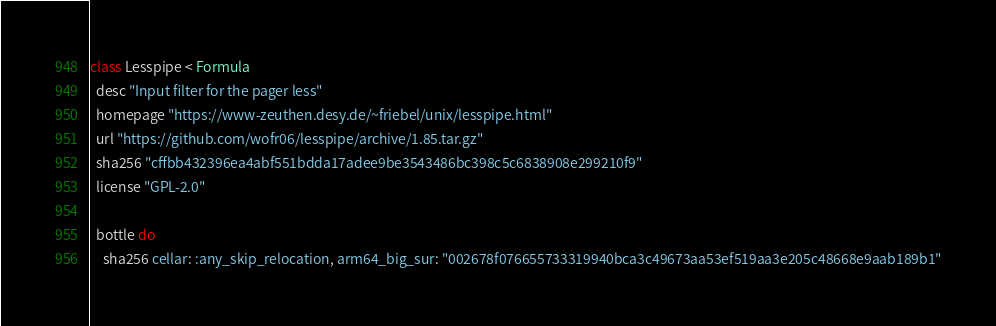Convert code to text. <code><loc_0><loc_0><loc_500><loc_500><_Ruby_>class Lesspipe < Formula
  desc "Input filter for the pager less"
  homepage "https://www-zeuthen.desy.de/~friebel/unix/lesspipe.html"
  url "https://github.com/wofr06/lesspipe/archive/1.85.tar.gz"
  sha256 "cffbb432396ea4abf551bdda17adee9be3543486bc398c5c6838908e299210f9"
  license "GPL-2.0"

  bottle do
    sha256 cellar: :any_skip_relocation, arm64_big_sur: "002678f076655733319940bca3c49673aa53ef519aa3e205c48668e9aab189b1"</code> 